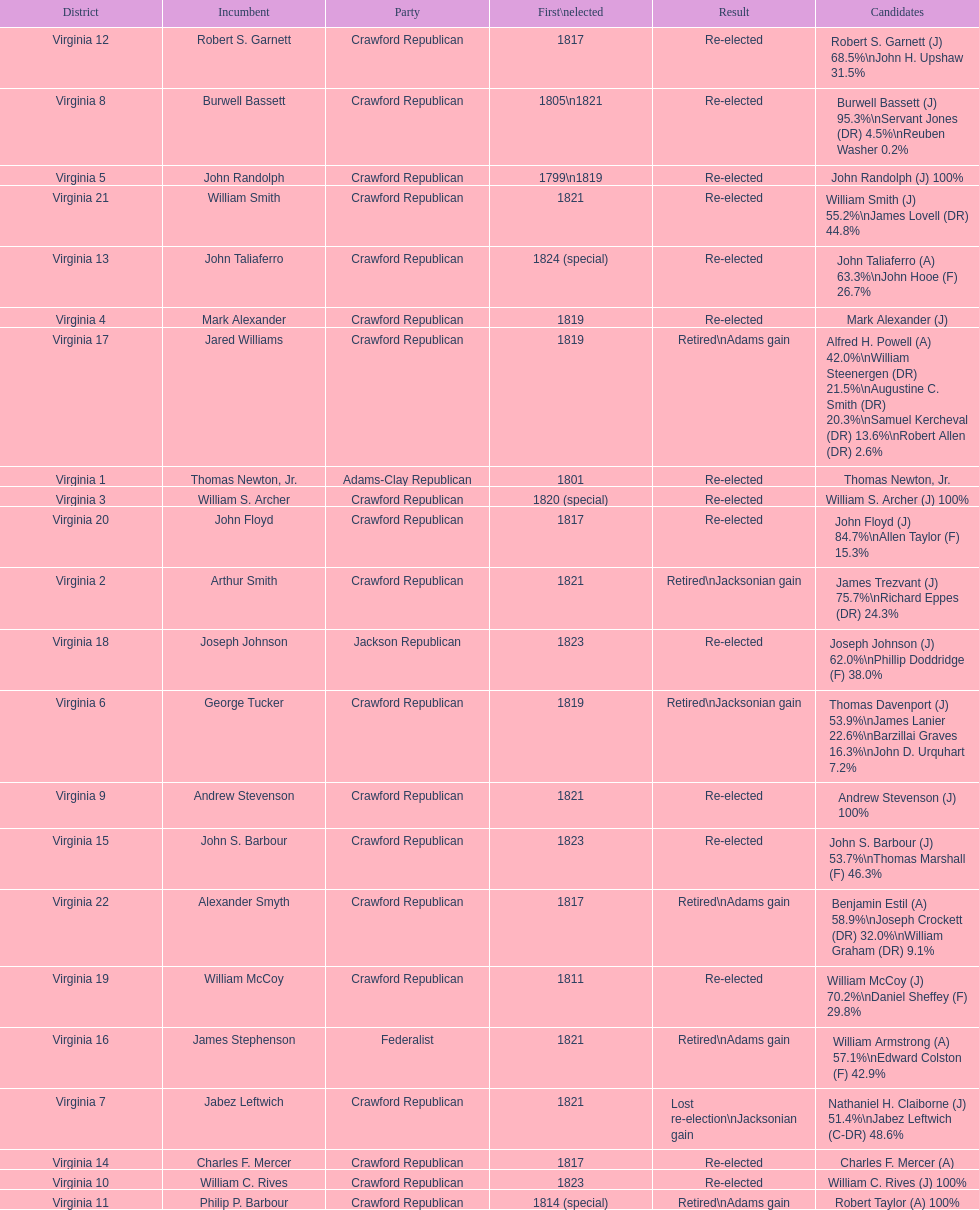What is the last party on this chart? Crawford Republican. 